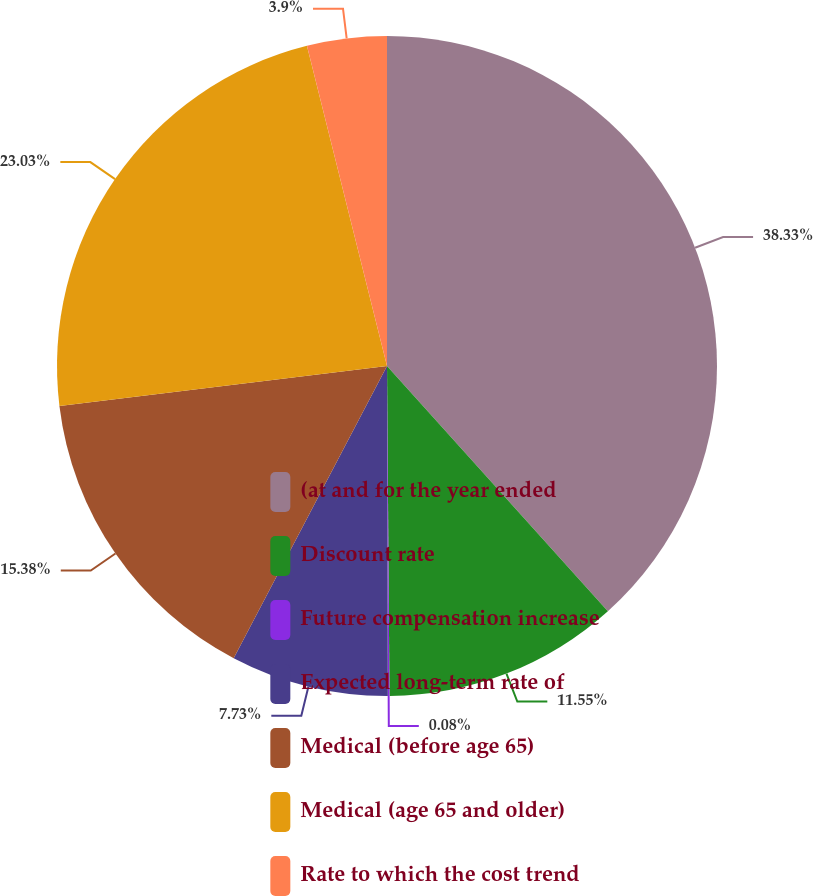Convert chart. <chart><loc_0><loc_0><loc_500><loc_500><pie_chart><fcel>(at and for the year ended<fcel>Discount rate<fcel>Future compensation increase<fcel>Expected long-term rate of<fcel>Medical (before age 65)<fcel>Medical (age 65 and older)<fcel>Rate to which the cost trend<nl><fcel>38.33%<fcel>11.55%<fcel>0.08%<fcel>7.73%<fcel>15.38%<fcel>23.03%<fcel>3.9%<nl></chart> 